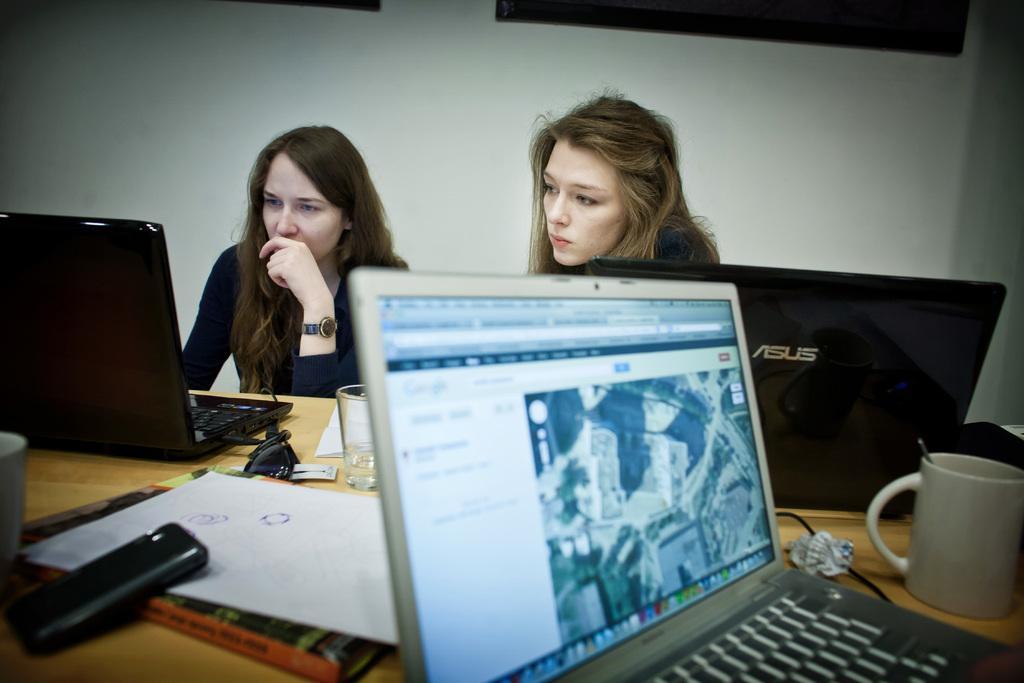Could you give a brief overview of what you see in this image? In this image in the front there is a table, on the table there are laptops, papers, glasses, there are objects which are black in colour. In the center there are persons sitting and in the background there is a wall, on the wall there are objects which are black in colour. 